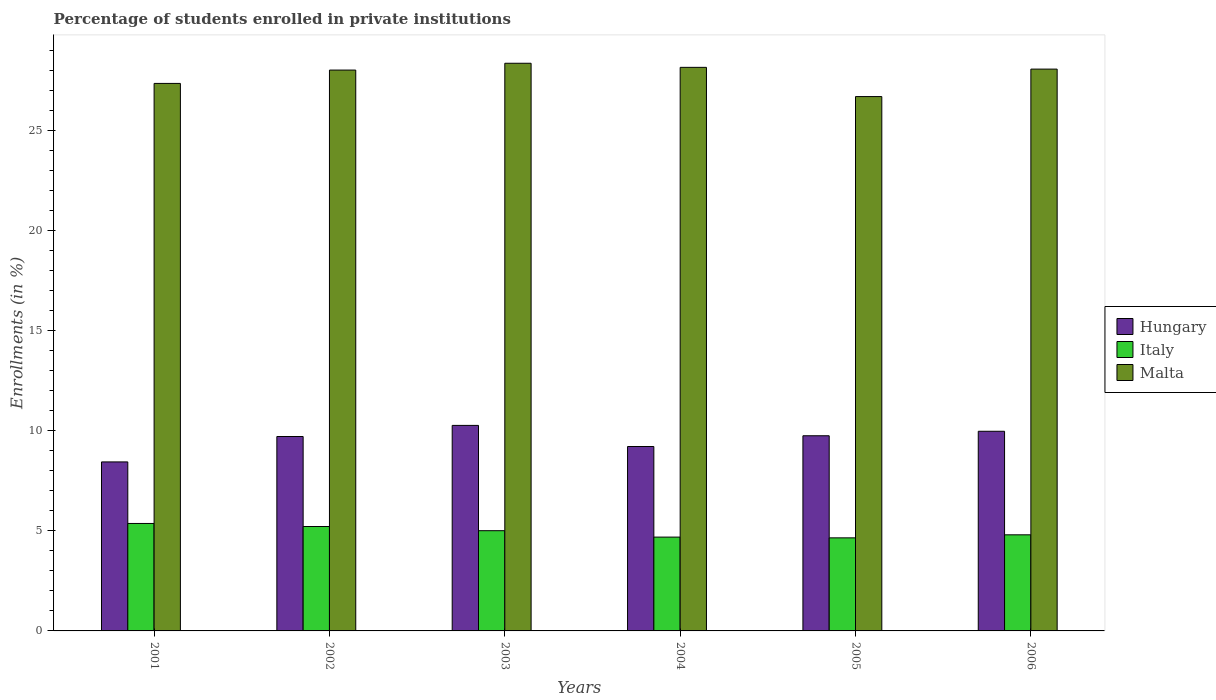How many different coloured bars are there?
Your answer should be very brief. 3. Are the number of bars on each tick of the X-axis equal?
Keep it short and to the point. Yes. How many bars are there on the 1st tick from the left?
Keep it short and to the point. 3. What is the percentage of trained teachers in Malta in 2001?
Your response must be concise. 27.37. Across all years, what is the maximum percentage of trained teachers in Malta?
Your answer should be compact. 28.38. Across all years, what is the minimum percentage of trained teachers in Italy?
Your answer should be compact. 4.65. In which year was the percentage of trained teachers in Italy maximum?
Give a very brief answer. 2001. In which year was the percentage of trained teachers in Malta minimum?
Provide a short and direct response. 2005. What is the total percentage of trained teachers in Italy in the graph?
Offer a terse response. 29.75. What is the difference between the percentage of trained teachers in Malta in 2002 and that in 2004?
Provide a short and direct response. -0.14. What is the difference between the percentage of trained teachers in Hungary in 2005 and the percentage of trained teachers in Italy in 2001?
Offer a very short reply. 4.38. What is the average percentage of trained teachers in Malta per year?
Your answer should be very brief. 27.79. In the year 2006, what is the difference between the percentage of trained teachers in Malta and percentage of trained teachers in Italy?
Make the answer very short. 23.28. What is the ratio of the percentage of trained teachers in Malta in 2004 to that in 2006?
Give a very brief answer. 1. Is the difference between the percentage of trained teachers in Malta in 2003 and 2005 greater than the difference between the percentage of trained teachers in Italy in 2003 and 2005?
Offer a very short reply. Yes. What is the difference between the highest and the second highest percentage of trained teachers in Italy?
Your answer should be compact. 0.15. What is the difference between the highest and the lowest percentage of trained teachers in Malta?
Make the answer very short. 1.67. Is it the case that in every year, the sum of the percentage of trained teachers in Italy and percentage of trained teachers in Hungary is greater than the percentage of trained teachers in Malta?
Provide a succinct answer. No. How many bars are there?
Give a very brief answer. 18. How many years are there in the graph?
Provide a succinct answer. 6. What is the difference between two consecutive major ticks on the Y-axis?
Provide a succinct answer. 5. Does the graph contain any zero values?
Make the answer very short. No. What is the title of the graph?
Offer a terse response. Percentage of students enrolled in private institutions. Does "Monaco" appear as one of the legend labels in the graph?
Ensure brevity in your answer.  No. What is the label or title of the X-axis?
Make the answer very short. Years. What is the label or title of the Y-axis?
Your answer should be compact. Enrollments (in %). What is the Enrollments (in %) in Hungary in 2001?
Give a very brief answer. 8.45. What is the Enrollments (in %) of Italy in 2001?
Provide a short and direct response. 5.37. What is the Enrollments (in %) of Malta in 2001?
Provide a succinct answer. 27.37. What is the Enrollments (in %) in Hungary in 2002?
Your answer should be compact. 9.72. What is the Enrollments (in %) in Italy in 2002?
Make the answer very short. 5.22. What is the Enrollments (in %) in Malta in 2002?
Provide a succinct answer. 28.04. What is the Enrollments (in %) of Hungary in 2003?
Make the answer very short. 10.27. What is the Enrollments (in %) in Italy in 2003?
Provide a short and direct response. 5.01. What is the Enrollments (in %) in Malta in 2003?
Give a very brief answer. 28.38. What is the Enrollments (in %) of Hungary in 2004?
Offer a terse response. 9.22. What is the Enrollments (in %) in Italy in 2004?
Provide a short and direct response. 4.69. What is the Enrollments (in %) of Malta in 2004?
Provide a succinct answer. 28.17. What is the Enrollments (in %) in Hungary in 2005?
Give a very brief answer. 9.76. What is the Enrollments (in %) of Italy in 2005?
Provide a succinct answer. 4.65. What is the Enrollments (in %) of Malta in 2005?
Offer a very short reply. 26.71. What is the Enrollments (in %) in Hungary in 2006?
Ensure brevity in your answer.  9.98. What is the Enrollments (in %) in Italy in 2006?
Give a very brief answer. 4.8. What is the Enrollments (in %) in Malta in 2006?
Ensure brevity in your answer.  28.09. Across all years, what is the maximum Enrollments (in %) in Hungary?
Give a very brief answer. 10.27. Across all years, what is the maximum Enrollments (in %) of Italy?
Give a very brief answer. 5.37. Across all years, what is the maximum Enrollments (in %) in Malta?
Ensure brevity in your answer.  28.38. Across all years, what is the minimum Enrollments (in %) of Hungary?
Give a very brief answer. 8.45. Across all years, what is the minimum Enrollments (in %) in Italy?
Your answer should be very brief. 4.65. Across all years, what is the minimum Enrollments (in %) of Malta?
Provide a succinct answer. 26.71. What is the total Enrollments (in %) in Hungary in the graph?
Offer a very short reply. 57.4. What is the total Enrollments (in %) in Italy in the graph?
Offer a very short reply. 29.75. What is the total Enrollments (in %) of Malta in the graph?
Offer a very short reply. 166.76. What is the difference between the Enrollments (in %) in Hungary in 2001 and that in 2002?
Provide a succinct answer. -1.27. What is the difference between the Enrollments (in %) of Italy in 2001 and that in 2002?
Make the answer very short. 0.15. What is the difference between the Enrollments (in %) of Malta in 2001 and that in 2002?
Offer a terse response. -0.67. What is the difference between the Enrollments (in %) in Hungary in 2001 and that in 2003?
Offer a terse response. -1.83. What is the difference between the Enrollments (in %) of Italy in 2001 and that in 2003?
Give a very brief answer. 0.36. What is the difference between the Enrollments (in %) in Malta in 2001 and that in 2003?
Your answer should be compact. -1.01. What is the difference between the Enrollments (in %) of Hungary in 2001 and that in 2004?
Offer a terse response. -0.77. What is the difference between the Enrollments (in %) in Italy in 2001 and that in 2004?
Your answer should be very brief. 0.68. What is the difference between the Enrollments (in %) in Malta in 2001 and that in 2004?
Ensure brevity in your answer.  -0.8. What is the difference between the Enrollments (in %) of Hungary in 2001 and that in 2005?
Provide a short and direct response. -1.31. What is the difference between the Enrollments (in %) in Italy in 2001 and that in 2005?
Provide a short and direct response. 0.72. What is the difference between the Enrollments (in %) in Malta in 2001 and that in 2005?
Your response must be concise. 0.66. What is the difference between the Enrollments (in %) of Hungary in 2001 and that in 2006?
Provide a succinct answer. -1.53. What is the difference between the Enrollments (in %) in Italy in 2001 and that in 2006?
Give a very brief answer. 0.57. What is the difference between the Enrollments (in %) in Malta in 2001 and that in 2006?
Keep it short and to the point. -0.72. What is the difference between the Enrollments (in %) in Hungary in 2002 and that in 2003?
Your answer should be compact. -0.56. What is the difference between the Enrollments (in %) of Italy in 2002 and that in 2003?
Your answer should be very brief. 0.21. What is the difference between the Enrollments (in %) in Malta in 2002 and that in 2003?
Offer a terse response. -0.34. What is the difference between the Enrollments (in %) of Hungary in 2002 and that in 2004?
Your response must be concise. 0.5. What is the difference between the Enrollments (in %) of Italy in 2002 and that in 2004?
Offer a very short reply. 0.53. What is the difference between the Enrollments (in %) in Malta in 2002 and that in 2004?
Provide a short and direct response. -0.14. What is the difference between the Enrollments (in %) in Hungary in 2002 and that in 2005?
Your response must be concise. -0.04. What is the difference between the Enrollments (in %) in Italy in 2002 and that in 2005?
Keep it short and to the point. 0.57. What is the difference between the Enrollments (in %) in Malta in 2002 and that in 2005?
Keep it short and to the point. 1.32. What is the difference between the Enrollments (in %) of Hungary in 2002 and that in 2006?
Your answer should be compact. -0.26. What is the difference between the Enrollments (in %) in Italy in 2002 and that in 2006?
Offer a terse response. 0.41. What is the difference between the Enrollments (in %) of Malta in 2002 and that in 2006?
Give a very brief answer. -0.05. What is the difference between the Enrollments (in %) of Hungary in 2003 and that in 2004?
Keep it short and to the point. 1.06. What is the difference between the Enrollments (in %) in Italy in 2003 and that in 2004?
Your answer should be compact. 0.32. What is the difference between the Enrollments (in %) of Malta in 2003 and that in 2004?
Give a very brief answer. 0.2. What is the difference between the Enrollments (in %) of Hungary in 2003 and that in 2005?
Give a very brief answer. 0.52. What is the difference between the Enrollments (in %) of Italy in 2003 and that in 2005?
Your response must be concise. 0.36. What is the difference between the Enrollments (in %) of Malta in 2003 and that in 2005?
Keep it short and to the point. 1.67. What is the difference between the Enrollments (in %) of Hungary in 2003 and that in 2006?
Your answer should be very brief. 0.29. What is the difference between the Enrollments (in %) in Italy in 2003 and that in 2006?
Your answer should be compact. 0.21. What is the difference between the Enrollments (in %) in Malta in 2003 and that in 2006?
Make the answer very short. 0.29. What is the difference between the Enrollments (in %) of Hungary in 2004 and that in 2005?
Offer a very short reply. -0.54. What is the difference between the Enrollments (in %) in Italy in 2004 and that in 2005?
Keep it short and to the point. 0.04. What is the difference between the Enrollments (in %) of Malta in 2004 and that in 2005?
Your answer should be very brief. 1.46. What is the difference between the Enrollments (in %) of Hungary in 2004 and that in 2006?
Provide a succinct answer. -0.76. What is the difference between the Enrollments (in %) in Italy in 2004 and that in 2006?
Provide a succinct answer. -0.11. What is the difference between the Enrollments (in %) in Malta in 2004 and that in 2006?
Your answer should be very brief. 0.09. What is the difference between the Enrollments (in %) in Hungary in 2005 and that in 2006?
Give a very brief answer. -0.22. What is the difference between the Enrollments (in %) of Italy in 2005 and that in 2006?
Provide a short and direct response. -0.15. What is the difference between the Enrollments (in %) in Malta in 2005 and that in 2006?
Offer a very short reply. -1.37. What is the difference between the Enrollments (in %) of Hungary in 2001 and the Enrollments (in %) of Italy in 2002?
Your answer should be compact. 3.23. What is the difference between the Enrollments (in %) in Hungary in 2001 and the Enrollments (in %) in Malta in 2002?
Offer a very short reply. -19.59. What is the difference between the Enrollments (in %) in Italy in 2001 and the Enrollments (in %) in Malta in 2002?
Offer a very short reply. -22.67. What is the difference between the Enrollments (in %) in Hungary in 2001 and the Enrollments (in %) in Italy in 2003?
Your response must be concise. 3.44. What is the difference between the Enrollments (in %) in Hungary in 2001 and the Enrollments (in %) in Malta in 2003?
Your answer should be very brief. -19.93. What is the difference between the Enrollments (in %) of Italy in 2001 and the Enrollments (in %) of Malta in 2003?
Provide a succinct answer. -23.01. What is the difference between the Enrollments (in %) of Hungary in 2001 and the Enrollments (in %) of Italy in 2004?
Your answer should be compact. 3.76. What is the difference between the Enrollments (in %) of Hungary in 2001 and the Enrollments (in %) of Malta in 2004?
Make the answer very short. -19.73. What is the difference between the Enrollments (in %) in Italy in 2001 and the Enrollments (in %) in Malta in 2004?
Your answer should be very brief. -22.8. What is the difference between the Enrollments (in %) in Hungary in 2001 and the Enrollments (in %) in Italy in 2005?
Offer a terse response. 3.8. What is the difference between the Enrollments (in %) of Hungary in 2001 and the Enrollments (in %) of Malta in 2005?
Keep it short and to the point. -18.26. What is the difference between the Enrollments (in %) of Italy in 2001 and the Enrollments (in %) of Malta in 2005?
Give a very brief answer. -21.34. What is the difference between the Enrollments (in %) in Hungary in 2001 and the Enrollments (in %) in Italy in 2006?
Your answer should be compact. 3.64. What is the difference between the Enrollments (in %) in Hungary in 2001 and the Enrollments (in %) in Malta in 2006?
Give a very brief answer. -19.64. What is the difference between the Enrollments (in %) in Italy in 2001 and the Enrollments (in %) in Malta in 2006?
Give a very brief answer. -22.71. What is the difference between the Enrollments (in %) of Hungary in 2002 and the Enrollments (in %) of Italy in 2003?
Offer a terse response. 4.71. What is the difference between the Enrollments (in %) of Hungary in 2002 and the Enrollments (in %) of Malta in 2003?
Ensure brevity in your answer.  -18.66. What is the difference between the Enrollments (in %) of Italy in 2002 and the Enrollments (in %) of Malta in 2003?
Offer a very short reply. -23.16. What is the difference between the Enrollments (in %) in Hungary in 2002 and the Enrollments (in %) in Italy in 2004?
Provide a short and direct response. 5.03. What is the difference between the Enrollments (in %) of Hungary in 2002 and the Enrollments (in %) of Malta in 2004?
Your answer should be compact. -18.46. What is the difference between the Enrollments (in %) in Italy in 2002 and the Enrollments (in %) in Malta in 2004?
Your response must be concise. -22.95. What is the difference between the Enrollments (in %) in Hungary in 2002 and the Enrollments (in %) in Italy in 2005?
Give a very brief answer. 5.07. What is the difference between the Enrollments (in %) of Hungary in 2002 and the Enrollments (in %) of Malta in 2005?
Provide a short and direct response. -16.99. What is the difference between the Enrollments (in %) in Italy in 2002 and the Enrollments (in %) in Malta in 2005?
Provide a succinct answer. -21.49. What is the difference between the Enrollments (in %) of Hungary in 2002 and the Enrollments (in %) of Italy in 2006?
Your answer should be very brief. 4.91. What is the difference between the Enrollments (in %) in Hungary in 2002 and the Enrollments (in %) in Malta in 2006?
Offer a terse response. -18.37. What is the difference between the Enrollments (in %) of Italy in 2002 and the Enrollments (in %) of Malta in 2006?
Provide a succinct answer. -22.87. What is the difference between the Enrollments (in %) in Hungary in 2003 and the Enrollments (in %) in Italy in 2004?
Ensure brevity in your answer.  5.58. What is the difference between the Enrollments (in %) in Hungary in 2003 and the Enrollments (in %) in Malta in 2004?
Offer a terse response. -17.9. What is the difference between the Enrollments (in %) in Italy in 2003 and the Enrollments (in %) in Malta in 2004?
Make the answer very short. -23.16. What is the difference between the Enrollments (in %) in Hungary in 2003 and the Enrollments (in %) in Italy in 2005?
Your answer should be very brief. 5.62. What is the difference between the Enrollments (in %) in Hungary in 2003 and the Enrollments (in %) in Malta in 2005?
Your response must be concise. -16.44. What is the difference between the Enrollments (in %) of Italy in 2003 and the Enrollments (in %) of Malta in 2005?
Offer a terse response. -21.7. What is the difference between the Enrollments (in %) in Hungary in 2003 and the Enrollments (in %) in Italy in 2006?
Give a very brief answer. 5.47. What is the difference between the Enrollments (in %) in Hungary in 2003 and the Enrollments (in %) in Malta in 2006?
Provide a succinct answer. -17.81. What is the difference between the Enrollments (in %) in Italy in 2003 and the Enrollments (in %) in Malta in 2006?
Make the answer very short. -23.08. What is the difference between the Enrollments (in %) in Hungary in 2004 and the Enrollments (in %) in Italy in 2005?
Offer a very short reply. 4.57. What is the difference between the Enrollments (in %) of Hungary in 2004 and the Enrollments (in %) of Malta in 2005?
Provide a succinct answer. -17.49. What is the difference between the Enrollments (in %) in Italy in 2004 and the Enrollments (in %) in Malta in 2005?
Provide a short and direct response. -22.02. What is the difference between the Enrollments (in %) in Hungary in 2004 and the Enrollments (in %) in Italy in 2006?
Keep it short and to the point. 4.41. What is the difference between the Enrollments (in %) in Hungary in 2004 and the Enrollments (in %) in Malta in 2006?
Provide a succinct answer. -18.87. What is the difference between the Enrollments (in %) in Italy in 2004 and the Enrollments (in %) in Malta in 2006?
Give a very brief answer. -23.4. What is the difference between the Enrollments (in %) in Hungary in 2005 and the Enrollments (in %) in Italy in 2006?
Your response must be concise. 4.95. What is the difference between the Enrollments (in %) in Hungary in 2005 and the Enrollments (in %) in Malta in 2006?
Offer a very short reply. -18.33. What is the difference between the Enrollments (in %) of Italy in 2005 and the Enrollments (in %) of Malta in 2006?
Offer a terse response. -23.43. What is the average Enrollments (in %) in Hungary per year?
Give a very brief answer. 9.57. What is the average Enrollments (in %) of Italy per year?
Your answer should be compact. 4.96. What is the average Enrollments (in %) in Malta per year?
Provide a short and direct response. 27.79. In the year 2001, what is the difference between the Enrollments (in %) of Hungary and Enrollments (in %) of Italy?
Your answer should be compact. 3.08. In the year 2001, what is the difference between the Enrollments (in %) of Hungary and Enrollments (in %) of Malta?
Provide a short and direct response. -18.92. In the year 2001, what is the difference between the Enrollments (in %) in Italy and Enrollments (in %) in Malta?
Make the answer very short. -22. In the year 2002, what is the difference between the Enrollments (in %) in Hungary and Enrollments (in %) in Italy?
Ensure brevity in your answer.  4.5. In the year 2002, what is the difference between the Enrollments (in %) in Hungary and Enrollments (in %) in Malta?
Your answer should be very brief. -18.32. In the year 2002, what is the difference between the Enrollments (in %) of Italy and Enrollments (in %) of Malta?
Keep it short and to the point. -22.82. In the year 2003, what is the difference between the Enrollments (in %) in Hungary and Enrollments (in %) in Italy?
Make the answer very short. 5.26. In the year 2003, what is the difference between the Enrollments (in %) in Hungary and Enrollments (in %) in Malta?
Offer a terse response. -18.1. In the year 2003, what is the difference between the Enrollments (in %) in Italy and Enrollments (in %) in Malta?
Ensure brevity in your answer.  -23.37. In the year 2004, what is the difference between the Enrollments (in %) in Hungary and Enrollments (in %) in Italy?
Give a very brief answer. 4.53. In the year 2004, what is the difference between the Enrollments (in %) in Hungary and Enrollments (in %) in Malta?
Provide a succinct answer. -18.96. In the year 2004, what is the difference between the Enrollments (in %) of Italy and Enrollments (in %) of Malta?
Your answer should be very brief. -23.48. In the year 2005, what is the difference between the Enrollments (in %) of Hungary and Enrollments (in %) of Italy?
Offer a terse response. 5.1. In the year 2005, what is the difference between the Enrollments (in %) of Hungary and Enrollments (in %) of Malta?
Ensure brevity in your answer.  -16.96. In the year 2005, what is the difference between the Enrollments (in %) of Italy and Enrollments (in %) of Malta?
Keep it short and to the point. -22.06. In the year 2006, what is the difference between the Enrollments (in %) of Hungary and Enrollments (in %) of Italy?
Make the answer very short. 5.18. In the year 2006, what is the difference between the Enrollments (in %) in Hungary and Enrollments (in %) in Malta?
Offer a very short reply. -18.11. In the year 2006, what is the difference between the Enrollments (in %) of Italy and Enrollments (in %) of Malta?
Offer a very short reply. -23.28. What is the ratio of the Enrollments (in %) of Hungary in 2001 to that in 2002?
Ensure brevity in your answer.  0.87. What is the ratio of the Enrollments (in %) of Italy in 2001 to that in 2002?
Provide a succinct answer. 1.03. What is the ratio of the Enrollments (in %) in Malta in 2001 to that in 2002?
Your answer should be very brief. 0.98. What is the ratio of the Enrollments (in %) in Hungary in 2001 to that in 2003?
Your response must be concise. 0.82. What is the ratio of the Enrollments (in %) in Italy in 2001 to that in 2003?
Give a very brief answer. 1.07. What is the ratio of the Enrollments (in %) in Malta in 2001 to that in 2003?
Make the answer very short. 0.96. What is the ratio of the Enrollments (in %) in Hungary in 2001 to that in 2004?
Offer a very short reply. 0.92. What is the ratio of the Enrollments (in %) of Italy in 2001 to that in 2004?
Provide a succinct answer. 1.15. What is the ratio of the Enrollments (in %) of Malta in 2001 to that in 2004?
Ensure brevity in your answer.  0.97. What is the ratio of the Enrollments (in %) of Hungary in 2001 to that in 2005?
Make the answer very short. 0.87. What is the ratio of the Enrollments (in %) in Italy in 2001 to that in 2005?
Give a very brief answer. 1.15. What is the ratio of the Enrollments (in %) of Malta in 2001 to that in 2005?
Give a very brief answer. 1.02. What is the ratio of the Enrollments (in %) of Hungary in 2001 to that in 2006?
Ensure brevity in your answer.  0.85. What is the ratio of the Enrollments (in %) in Italy in 2001 to that in 2006?
Your answer should be compact. 1.12. What is the ratio of the Enrollments (in %) of Malta in 2001 to that in 2006?
Offer a very short reply. 0.97. What is the ratio of the Enrollments (in %) of Hungary in 2002 to that in 2003?
Offer a very short reply. 0.95. What is the ratio of the Enrollments (in %) of Italy in 2002 to that in 2003?
Keep it short and to the point. 1.04. What is the ratio of the Enrollments (in %) in Hungary in 2002 to that in 2004?
Keep it short and to the point. 1.05. What is the ratio of the Enrollments (in %) of Italy in 2002 to that in 2004?
Keep it short and to the point. 1.11. What is the ratio of the Enrollments (in %) of Malta in 2002 to that in 2004?
Provide a succinct answer. 1. What is the ratio of the Enrollments (in %) in Italy in 2002 to that in 2005?
Your answer should be very brief. 1.12. What is the ratio of the Enrollments (in %) in Malta in 2002 to that in 2005?
Offer a very short reply. 1.05. What is the ratio of the Enrollments (in %) in Hungary in 2002 to that in 2006?
Keep it short and to the point. 0.97. What is the ratio of the Enrollments (in %) of Italy in 2002 to that in 2006?
Provide a short and direct response. 1.09. What is the ratio of the Enrollments (in %) of Malta in 2002 to that in 2006?
Make the answer very short. 1. What is the ratio of the Enrollments (in %) in Hungary in 2003 to that in 2004?
Give a very brief answer. 1.11. What is the ratio of the Enrollments (in %) of Italy in 2003 to that in 2004?
Offer a very short reply. 1.07. What is the ratio of the Enrollments (in %) in Malta in 2003 to that in 2004?
Make the answer very short. 1.01. What is the ratio of the Enrollments (in %) in Hungary in 2003 to that in 2005?
Your answer should be compact. 1.05. What is the ratio of the Enrollments (in %) in Italy in 2003 to that in 2005?
Your answer should be compact. 1.08. What is the ratio of the Enrollments (in %) in Malta in 2003 to that in 2005?
Your answer should be very brief. 1.06. What is the ratio of the Enrollments (in %) of Hungary in 2003 to that in 2006?
Provide a succinct answer. 1.03. What is the ratio of the Enrollments (in %) of Italy in 2003 to that in 2006?
Keep it short and to the point. 1.04. What is the ratio of the Enrollments (in %) of Malta in 2003 to that in 2006?
Your response must be concise. 1.01. What is the ratio of the Enrollments (in %) of Hungary in 2004 to that in 2005?
Offer a very short reply. 0.94. What is the ratio of the Enrollments (in %) of Malta in 2004 to that in 2005?
Offer a very short reply. 1.05. What is the ratio of the Enrollments (in %) in Hungary in 2004 to that in 2006?
Your answer should be compact. 0.92. What is the ratio of the Enrollments (in %) of Italy in 2004 to that in 2006?
Provide a short and direct response. 0.98. What is the ratio of the Enrollments (in %) in Malta in 2004 to that in 2006?
Provide a succinct answer. 1. What is the ratio of the Enrollments (in %) of Hungary in 2005 to that in 2006?
Your answer should be compact. 0.98. What is the ratio of the Enrollments (in %) in Italy in 2005 to that in 2006?
Make the answer very short. 0.97. What is the ratio of the Enrollments (in %) of Malta in 2005 to that in 2006?
Your answer should be compact. 0.95. What is the difference between the highest and the second highest Enrollments (in %) in Hungary?
Offer a terse response. 0.29. What is the difference between the highest and the second highest Enrollments (in %) of Italy?
Ensure brevity in your answer.  0.15. What is the difference between the highest and the second highest Enrollments (in %) in Malta?
Provide a short and direct response. 0.2. What is the difference between the highest and the lowest Enrollments (in %) in Hungary?
Make the answer very short. 1.83. What is the difference between the highest and the lowest Enrollments (in %) of Italy?
Keep it short and to the point. 0.72. What is the difference between the highest and the lowest Enrollments (in %) of Malta?
Give a very brief answer. 1.67. 